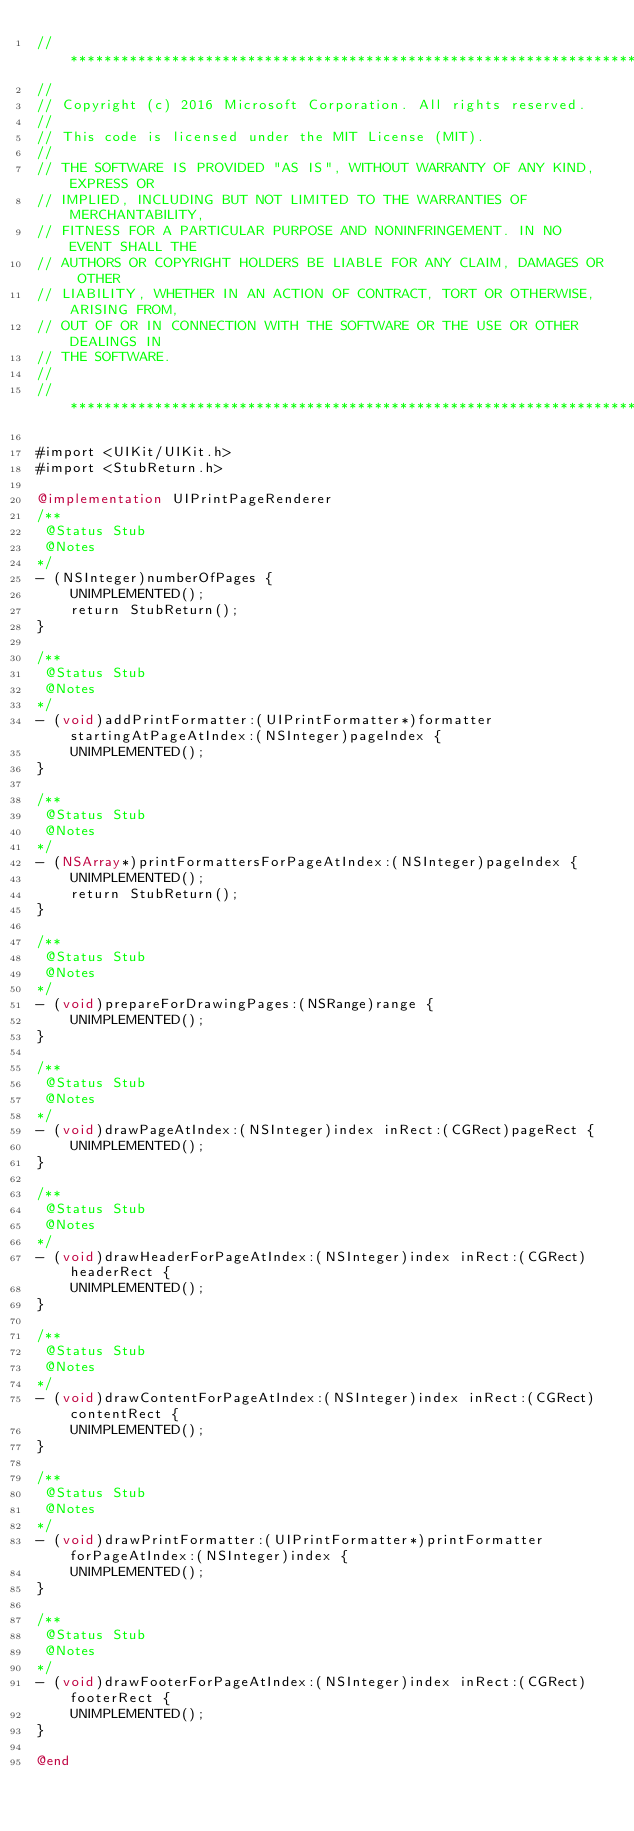Convert code to text. <code><loc_0><loc_0><loc_500><loc_500><_ObjectiveC_>//******************************************************************************
//
// Copyright (c) 2016 Microsoft Corporation. All rights reserved.
//
// This code is licensed under the MIT License (MIT).
//
// THE SOFTWARE IS PROVIDED "AS IS", WITHOUT WARRANTY OF ANY KIND, EXPRESS OR
// IMPLIED, INCLUDING BUT NOT LIMITED TO THE WARRANTIES OF MERCHANTABILITY,
// FITNESS FOR A PARTICULAR PURPOSE AND NONINFRINGEMENT. IN NO EVENT SHALL THE
// AUTHORS OR COPYRIGHT HOLDERS BE LIABLE FOR ANY CLAIM, DAMAGES OR OTHER
// LIABILITY, WHETHER IN AN ACTION OF CONTRACT, TORT OR OTHERWISE, ARISING FROM,
// OUT OF OR IN CONNECTION WITH THE SOFTWARE OR THE USE OR OTHER DEALINGS IN
// THE SOFTWARE.
//
//******************************************************************************

#import <UIKit/UIKit.h>
#import <StubReturn.h>

@implementation UIPrintPageRenderer
/**
 @Status Stub
 @Notes
*/
- (NSInteger)numberOfPages {
    UNIMPLEMENTED();
    return StubReturn();
}

/**
 @Status Stub
 @Notes
*/
- (void)addPrintFormatter:(UIPrintFormatter*)formatter startingAtPageAtIndex:(NSInteger)pageIndex {
    UNIMPLEMENTED();
}

/**
 @Status Stub
 @Notes
*/
- (NSArray*)printFormattersForPageAtIndex:(NSInteger)pageIndex {
    UNIMPLEMENTED();
    return StubReturn();
}

/**
 @Status Stub
 @Notes
*/
- (void)prepareForDrawingPages:(NSRange)range {
    UNIMPLEMENTED();
}

/**
 @Status Stub
 @Notes
*/
- (void)drawPageAtIndex:(NSInteger)index inRect:(CGRect)pageRect {
    UNIMPLEMENTED();
}

/**
 @Status Stub
 @Notes
*/
- (void)drawHeaderForPageAtIndex:(NSInteger)index inRect:(CGRect)headerRect {
    UNIMPLEMENTED();
}

/**
 @Status Stub
 @Notes
*/
- (void)drawContentForPageAtIndex:(NSInteger)index inRect:(CGRect)contentRect {
    UNIMPLEMENTED();
}

/**
 @Status Stub
 @Notes
*/
- (void)drawPrintFormatter:(UIPrintFormatter*)printFormatter forPageAtIndex:(NSInteger)index {
    UNIMPLEMENTED();
}

/**
 @Status Stub
 @Notes
*/
- (void)drawFooterForPageAtIndex:(NSInteger)index inRect:(CGRect)footerRect {
    UNIMPLEMENTED();
}

@end
</code> 